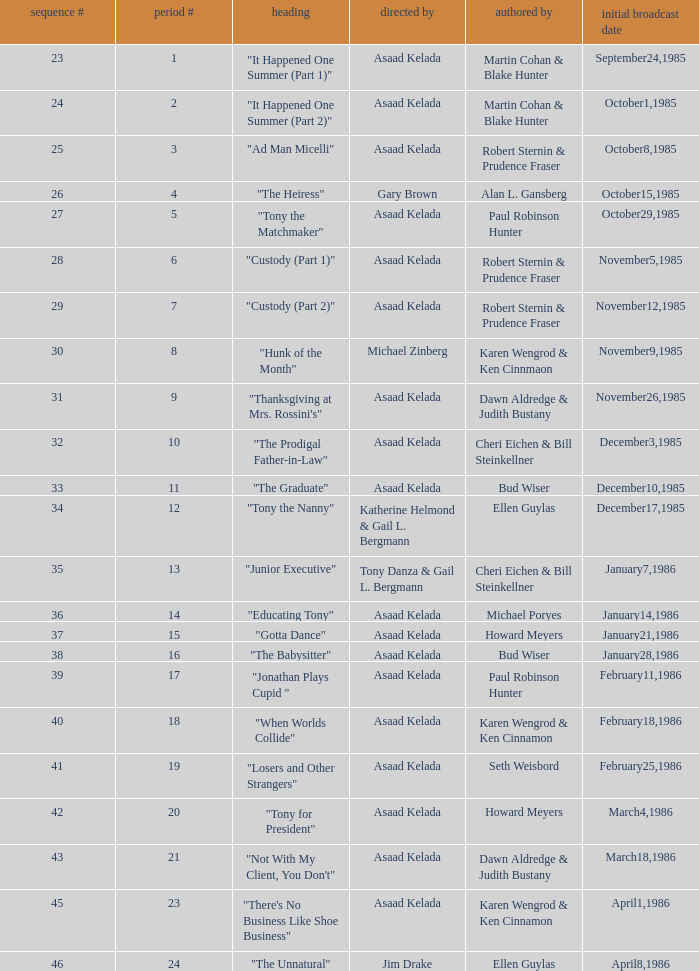Who were the authors of series episode #25? Robert Sternin & Prudence Fraser. 